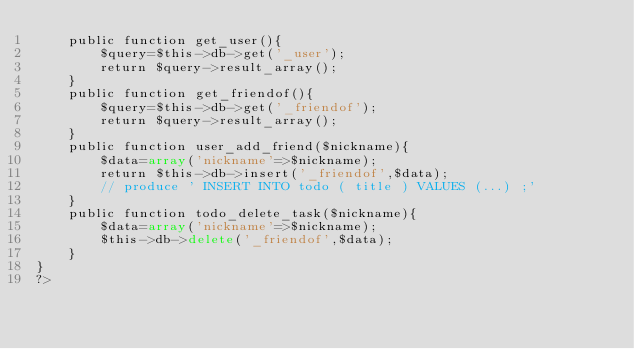Convert code to text. <code><loc_0><loc_0><loc_500><loc_500><_PHP_>	public function get_user(){
		$query=$this->db->get('_user');
		return $query->result_array();
	}
	public function get_friendof(){
		$query=$this->db->get('_friendof');
		return $query->result_array();
	}
	public function user_add_friend($nickname){
		$data=array('nickname'=>$nickname);
		return $this->db->insert('_friendof',$data);
		// produce ' INSERT INTO todo ( title ) VALUES (...) ;'
	}
	public function todo_delete_task($nickname){
		$data=array('nickname'=>$nickname);
		$this->db->delete('_friendof',$data);
	}
}
?>
</code> 